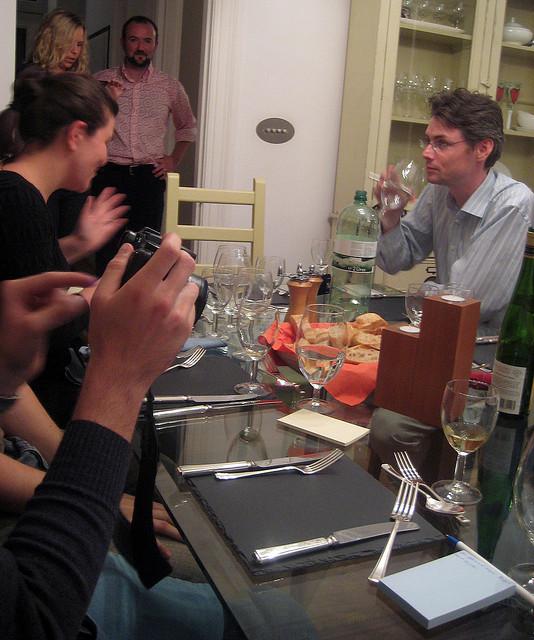Are they eating yet?
Keep it brief. No. How many glasses are at the table?
Be succinct. 7. Is it likely that the glass in the foreground once contained wine?
Write a very short answer. Yes. Is a man watching the people?
Short answer required. Yes. How many knives are on the cutting board?
Answer briefly. 2. How many red wines glasses are on the table?
Answer briefly. 0. How many people are wearing glasses?
Write a very short answer. 1. 